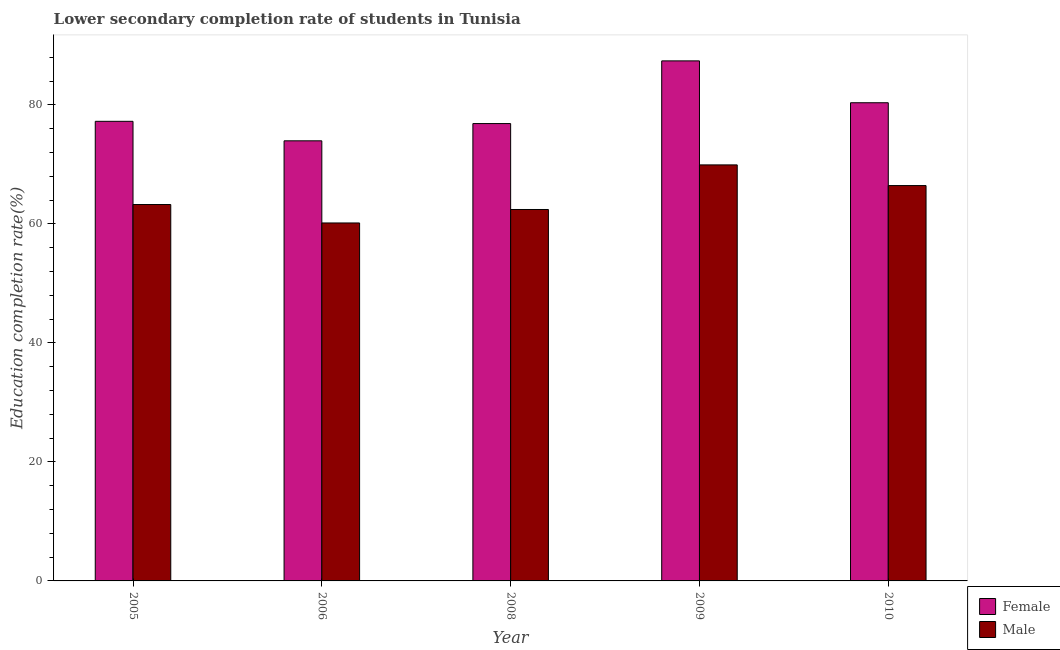How many different coloured bars are there?
Ensure brevity in your answer.  2. How many groups of bars are there?
Offer a terse response. 5. Are the number of bars per tick equal to the number of legend labels?
Make the answer very short. Yes. Are the number of bars on each tick of the X-axis equal?
Provide a short and direct response. Yes. How many bars are there on the 2nd tick from the left?
Ensure brevity in your answer.  2. What is the label of the 4th group of bars from the left?
Your answer should be compact. 2009. What is the education completion rate of female students in 2009?
Offer a very short reply. 87.39. Across all years, what is the maximum education completion rate of female students?
Your answer should be compact. 87.39. Across all years, what is the minimum education completion rate of male students?
Make the answer very short. 60.15. In which year was the education completion rate of male students maximum?
Ensure brevity in your answer.  2009. In which year was the education completion rate of female students minimum?
Your answer should be compact. 2006. What is the total education completion rate of female students in the graph?
Your answer should be compact. 395.77. What is the difference between the education completion rate of male students in 2006 and that in 2010?
Make the answer very short. -6.28. What is the difference between the education completion rate of male students in 2005 and the education completion rate of female students in 2006?
Your response must be concise. 3.1. What is the average education completion rate of male students per year?
Your answer should be compact. 64.43. What is the ratio of the education completion rate of male students in 2009 to that in 2010?
Give a very brief answer. 1.05. What is the difference between the highest and the second highest education completion rate of female students?
Provide a short and direct response. 7.03. What is the difference between the highest and the lowest education completion rate of male students?
Offer a terse response. 9.76. How many bars are there?
Offer a terse response. 10. Are all the bars in the graph horizontal?
Your answer should be very brief. No. How many years are there in the graph?
Your answer should be compact. 5. What is the difference between two consecutive major ticks on the Y-axis?
Give a very brief answer. 20. Does the graph contain any zero values?
Your answer should be compact. No. Where does the legend appear in the graph?
Offer a very short reply. Bottom right. How many legend labels are there?
Make the answer very short. 2. What is the title of the graph?
Give a very brief answer. Lower secondary completion rate of students in Tunisia. What is the label or title of the X-axis?
Your answer should be compact. Year. What is the label or title of the Y-axis?
Offer a very short reply. Education completion rate(%). What is the Education completion rate(%) of Female in 2005?
Your response must be concise. 77.23. What is the Education completion rate(%) of Male in 2005?
Offer a very short reply. 63.25. What is the Education completion rate(%) of Female in 2006?
Provide a short and direct response. 73.95. What is the Education completion rate(%) of Male in 2006?
Offer a terse response. 60.15. What is the Education completion rate(%) of Female in 2008?
Provide a short and direct response. 76.85. What is the Education completion rate(%) of Male in 2008?
Your response must be concise. 62.41. What is the Education completion rate(%) in Female in 2009?
Make the answer very short. 87.39. What is the Education completion rate(%) in Male in 2009?
Your answer should be compact. 69.91. What is the Education completion rate(%) in Female in 2010?
Your answer should be very brief. 80.35. What is the Education completion rate(%) of Male in 2010?
Your response must be concise. 66.43. Across all years, what is the maximum Education completion rate(%) in Female?
Provide a succinct answer. 87.39. Across all years, what is the maximum Education completion rate(%) of Male?
Give a very brief answer. 69.91. Across all years, what is the minimum Education completion rate(%) of Female?
Provide a short and direct response. 73.95. Across all years, what is the minimum Education completion rate(%) in Male?
Offer a terse response. 60.15. What is the total Education completion rate(%) in Female in the graph?
Make the answer very short. 395.77. What is the total Education completion rate(%) in Male in the graph?
Offer a very short reply. 322.15. What is the difference between the Education completion rate(%) in Female in 2005 and that in 2006?
Ensure brevity in your answer.  3.28. What is the difference between the Education completion rate(%) in Male in 2005 and that in 2006?
Provide a succinct answer. 3.1. What is the difference between the Education completion rate(%) in Female in 2005 and that in 2008?
Ensure brevity in your answer.  0.38. What is the difference between the Education completion rate(%) of Male in 2005 and that in 2008?
Your answer should be very brief. 0.83. What is the difference between the Education completion rate(%) of Female in 2005 and that in 2009?
Provide a short and direct response. -10.16. What is the difference between the Education completion rate(%) of Male in 2005 and that in 2009?
Ensure brevity in your answer.  -6.66. What is the difference between the Education completion rate(%) in Female in 2005 and that in 2010?
Make the answer very short. -3.12. What is the difference between the Education completion rate(%) of Male in 2005 and that in 2010?
Your answer should be compact. -3.18. What is the difference between the Education completion rate(%) in Female in 2006 and that in 2008?
Offer a very short reply. -2.9. What is the difference between the Education completion rate(%) in Male in 2006 and that in 2008?
Provide a short and direct response. -2.26. What is the difference between the Education completion rate(%) of Female in 2006 and that in 2009?
Your answer should be very brief. -13.43. What is the difference between the Education completion rate(%) in Male in 2006 and that in 2009?
Give a very brief answer. -9.76. What is the difference between the Education completion rate(%) of Female in 2006 and that in 2010?
Provide a succinct answer. -6.4. What is the difference between the Education completion rate(%) in Male in 2006 and that in 2010?
Provide a succinct answer. -6.28. What is the difference between the Education completion rate(%) of Female in 2008 and that in 2009?
Make the answer very short. -10.53. What is the difference between the Education completion rate(%) in Male in 2008 and that in 2009?
Offer a terse response. -7.49. What is the difference between the Education completion rate(%) in Female in 2008 and that in 2010?
Your response must be concise. -3.5. What is the difference between the Education completion rate(%) of Male in 2008 and that in 2010?
Make the answer very short. -4.02. What is the difference between the Education completion rate(%) of Female in 2009 and that in 2010?
Keep it short and to the point. 7.03. What is the difference between the Education completion rate(%) of Male in 2009 and that in 2010?
Give a very brief answer. 3.48. What is the difference between the Education completion rate(%) in Female in 2005 and the Education completion rate(%) in Male in 2006?
Your answer should be very brief. 17.08. What is the difference between the Education completion rate(%) of Female in 2005 and the Education completion rate(%) of Male in 2008?
Give a very brief answer. 14.82. What is the difference between the Education completion rate(%) of Female in 2005 and the Education completion rate(%) of Male in 2009?
Keep it short and to the point. 7.32. What is the difference between the Education completion rate(%) in Female in 2005 and the Education completion rate(%) in Male in 2010?
Provide a short and direct response. 10.8. What is the difference between the Education completion rate(%) in Female in 2006 and the Education completion rate(%) in Male in 2008?
Provide a succinct answer. 11.54. What is the difference between the Education completion rate(%) of Female in 2006 and the Education completion rate(%) of Male in 2009?
Provide a short and direct response. 4.04. What is the difference between the Education completion rate(%) of Female in 2006 and the Education completion rate(%) of Male in 2010?
Keep it short and to the point. 7.52. What is the difference between the Education completion rate(%) of Female in 2008 and the Education completion rate(%) of Male in 2009?
Your response must be concise. 6.94. What is the difference between the Education completion rate(%) in Female in 2008 and the Education completion rate(%) in Male in 2010?
Your response must be concise. 10.42. What is the difference between the Education completion rate(%) in Female in 2009 and the Education completion rate(%) in Male in 2010?
Keep it short and to the point. 20.95. What is the average Education completion rate(%) of Female per year?
Make the answer very short. 79.15. What is the average Education completion rate(%) of Male per year?
Provide a short and direct response. 64.43. In the year 2005, what is the difference between the Education completion rate(%) of Female and Education completion rate(%) of Male?
Keep it short and to the point. 13.98. In the year 2006, what is the difference between the Education completion rate(%) in Female and Education completion rate(%) in Male?
Your response must be concise. 13.8. In the year 2008, what is the difference between the Education completion rate(%) in Female and Education completion rate(%) in Male?
Give a very brief answer. 14.44. In the year 2009, what is the difference between the Education completion rate(%) in Female and Education completion rate(%) in Male?
Offer a very short reply. 17.48. In the year 2010, what is the difference between the Education completion rate(%) in Female and Education completion rate(%) in Male?
Make the answer very short. 13.92. What is the ratio of the Education completion rate(%) of Female in 2005 to that in 2006?
Provide a succinct answer. 1.04. What is the ratio of the Education completion rate(%) in Male in 2005 to that in 2006?
Offer a terse response. 1.05. What is the ratio of the Education completion rate(%) of Female in 2005 to that in 2008?
Your answer should be compact. 1. What is the ratio of the Education completion rate(%) of Male in 2005 to that in 2008?
Make the answer very short. 1.01. What is the ratio of the Education completion rate(%) of Female in 2005 to that in 2009?
Keep it short and to the point. 0.88. What is the ratio of the Education completion rate(%) of Male in 2005 to that in 2009?
Provide a succinct answer. 0.9. What is the ratio of the Education completion rate(%) in Female in 2005 to that in 2010?
Provide a succinct answer. 0.96. What is the ratio of the Education completion rate(%) of Male in 2005 to that in 2010?
Ensure brevity in your answer.  0.95. What is the ratio of the Education completion rate(%) in Female in 2006 to that in 2008?
Give a very brief answer. 0.96. What is the ratio of the Education completion rate(%) in Male in 2006 to that in 2008?
Your answer should be compact. 0.96. What is the ratio of the Education completion rate(%) in Female in 2006 to that in 2009?
Your answer should be very brief. 0.85. What is the ratio of the Education completion rate(%) in Male in 2006 to that in 2009?
Provide a short and direct response. 0.86. What is the ratio of the Education completion rate(%) of Female in 2006 to that in 2010?
Offer a very short reply. 0.92. What is the ratio of the Education completion rate(%) of Male in 2006 to that in 2010?
Make the answer very short. 0.91. What is the ratio of the Education completion rate(%) of Female in 2008 to that in 2009?
Provide a short and direct response. 0.88. What is the ratio of the Education completion rate(%) of Male in 2008 to that in 2009?
Offer a terse response. 0.89. What is the ratio of the Education completion rate(%) of Female in 2008 to that in 2010?
Offer a very short reply. 0.96. What is the ratio of the Education completion rate(%) in Male in 2008 to that in 2010?
Give a very brief answer. 0.94. What is the ratio of the Education completion rate(%) of Female in 2009 to that in 2010?
Offer a terse response. 1.09. What is the ratio of the Education completion rate(%) of Male in 2009 to that in 2010?
Your response must be concise. 1.05. What is the difference between the highest and the second highest Education completion rate(%) of Female?
Make the answer very short. 7.03. What is the difference between the highest and the second highest Education completion rate(%) in Male?
Ensure brevity in your answer.  3.48. What is the difference between the highest and the lowest Education completion rate(%) in Female?
Ensure brevity in your answer.  13.43. What is the difference between the highest and the lowest Education completion rate(%) in Male?
Offer a very short reply. 9.76. 